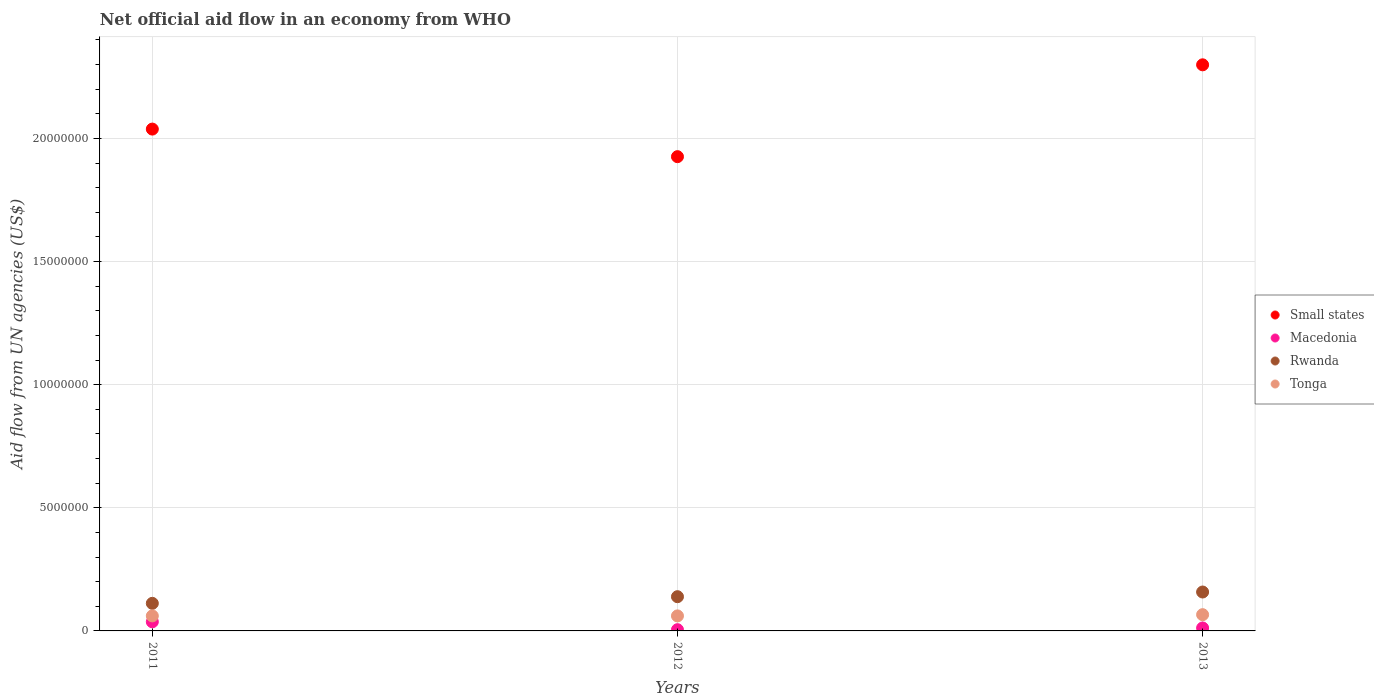How many different coloured dotlines are there?
Make the answer very short. 4. Across all years, what is the minimum net official aid flow in Macedonia?
Offer a terse response. 5.00e+04. What is the total net official aid flow in Tonga in the graph?
Your answer should be very brief. 1.88e+06. What is the difference between the net official aid flow in Macedonia in 2012 and that in 2013?
Give a very brief answer. -7.00e+04. What is the difference between the net official aid flow in Tonga in 2011 and the net official aid flow in Small states in 2013?
Your answer should be very brief. -2.24e+07. What is the average net official aid flow in Small states per year?
Your answer should be very brief. 2.09e+07. In the year 2013, what is the difference between the net official aid flow in Tonga and net official aid flow in Macedonia?
Your response must be concise. 5.40e+05. What is the ratio of the net official aid flow in Rwanda in 2012 to that in 2013?
Provide a short and direct response. 0.88. Is the net official aid flow in Macedonia in 2011 less than that in 2012?
Offer a terse response. No. Is the difference between the net official aid flow in Tonga in 2011 and 2012 greater than the difference between the net official aid flow in Macedonia in 2011 and 2012?
Provide a succinct answer. No. What is the difference between the highest and the second highest net official aid flow in Small states?
Make the answer very short. 2.61e+06. In how many years, is the net official aid flow in Macedonia greater than the average net official aid flow in Macedonia taken over all years?
Offer a very short reply. 1. Is it the case that in every year, the sum of the net official aid flow in Rwanda and net official aid flow in Small states  is greater than the sum of net official aid flow in Tonga and net official aid flow in Macedonia?
Your answer should be compact. Yes. Is it the case that in every year, the sum of the net official aid flow in Macedonia and net official aid flow in Rwanda  is greater than the net official aid flow in Tonga?
Provide a succinct answer. Yes. Does the net official aid flow in Macedonia monotonically increase over the years?
Provide a succinct answer. No. Is the net official aid flow in Macedonia strictly less than the net official aid flow in Tonga over the years?
Ensure brevity in your answer.  Yes. How many dotlines are there?
Offer a terse response. 4. How many years are there in the graph?
Give a very brief answer. 3. What is the difference between two consecutive major ticks on the Y-axis?
Give a very brief answer. 5.00e+06. Are the values on the major ticks of Y-axis written in scientific E-notation?
Your answer should be very brief. No. Does the graph contain any zero values?
Offer a terse response. No. Does the graph contain grids?
Keep it short and to the point. Yes. Where does the legend appear in the graph?
Your answer should be very brief. Center right. How many legend labels are there?
Provide a short and direct response. 4. How are the legend labels stacked?
Your answer should be very brief. Vertical. What is the title of the graph?
Keep it short and to the point. Net official aid flow in an economy from WHO. Does "Arab World" appear as one of the legend labels in the graph?
Keep it short and to the point. No. What is the label or title of the X-axis?
Your response must be concise. Years. What is the label or title of the Y-axis?
Provide a succinct answer. Aid flow from UN agencies (US$). What is the Aid flow from UN agencies (US$) in Small states in 2011?
Keep it short and to the point. 2.04e+07. What is the Aid flow from UN agencies (US$) of Rwanda in 2011?
Ensure brevity in your answer.  1.12e+06. What is the Aid flow from UN agencies (US$) of Tonga in 2011?
Ensure brevity in your answer.  6.10e+05. What is the Aid flow from UN agencies (US$) in Small states in 2012?
Your answer should be compact. 1.93e+07. What is the Aid flow from UN agencies (US$) in Macedonia in 2012?
Your answer should be compact. 5.00e+04. What is the Aid flow from UN agencies (US$) of Rwanda in 2012?
Offer a terse response. 1.39e+06. What is the Aid flow from UN agencies (US$) in Small states in 2013?
Give a very brief answer. 2.30e+07. What is the Aid flow from UN agencies (US$) of Macedonia in 2013?
Provide a short and direct response. 1.20e+05. What is the Aid flow from UN agencies (US$) of Rwanda in 2013?
Offer a terse response. 1.58e+06. Across all years, what is the maximum Aid flow from UN agencies (US$) in Small states?
Your answer should be very brief. 2.30e+07. Across all years, what is the maximum Aid flow from UN agencies (US$) in Macedonia?
Offer a very short reply. 3.70e+05. Across all years, what is the maximum Aid flow from UN agencies (US$) in Rwanda?
Provide a short and direct response. 1.58e+06. Across all years, what is the maximum Aid flow from UN agencies (US$) of Tonga?
Your response must be concise. 6.60e+05. Across all years, what is the minimum Aid flow from UN agencies (US$) in Small states?
Give a very brief answer. 1.93e+07. Across all years, what is the minimum Aid flow from UN agencies (US$) in Macedonia?
Your answer should be very brief. 5.00e+04. Across all years, what is the minimum Aid flow from UN agencies (US$) in Rwanda?
Offer a very short reply. 1.12e+06. Across all years, what is the minimum Aid flow from UN agencies (US$) in Tonga?
Make the answer very short. 6.10e+05. What is the total Aid flow from UN agencies (US$) in Small states in the graph?
Keep it short and to the point. 6.26e+07. What is the total Aid flow from UN agencies (US$) in Macedonia in the graph?
Offer a terse response. 5.40e+05. What is the total Aid flow from UN agencies (US$) of Rwanda in the graph?
Provide a short and direct response. 4.09e+06. What is the total Aid flow from UN agencies (US$) of Tonga in the graph?
Provide a succinct answer. 1.88e+06. What is the difference between the Aid flow from UN agencies (US$) in Small states in 2011 and that in 2012?
Keep it short and to the point. 1.12e+06. What is the difference between the Aid flow from UN agencies (US$) of Macedonia in 2011 and that in 2012?
Ensure brevity in your answer.  3.20e+05. What is the difference between the Aid flow from UN agencies (US$) of Small states in 2011 and that in 2013?
Provide a short and direct response. -2.61e+06. What is the difference between the Aid flow from UN agencies (US$) in Rwanda in 2011 and that in 2013?
Give a very brief answer. -4.60e+05. What is the difference between the Aid flow from UN agencies (US$) in Small states in 2012 and that in 2013?
Provide a succinct answer. -3.73e+06. What is the difference between the Aid flow from UN agencies (US$) of Tonga in 2012 and that in 2013?
Provide a succinct answer. -5.00e+04. What is the difference between the Aid flow from UN agencies (US$) of Small states in 2011 and the Aid flow from UN agencies (US$) of Macedonia in 2012?
Provide a short and direct response. 2.03e+07. What is the difference between the Aid flow from UN agencies (US$) in Small states in 2011 and the Aid flow from UN agencies (US$) in Rwanda in 2012?
Keep it short and to the point. 1.90e+07. What is the difference between the Aid flow from UN agencies (US$) in Small states in 2011 and the Aid flow from UN agencies (US$) in Tonga in 2012?
Offer a terse response. 1.98e+07. What is the difference between the Aid flow from UN agencies (US$) of Macedonia in 2011 and the Aid flow from UN agencies (US$) of Rwanda in 2012?
Keep it short and to the point. -1.02e+06. What is the difference between the Aid flow from UN agencies (US$) of Macedonia in 2011 and the Aid flow from UN agencies (US$) of Tonga in 2012?
Your answer should be very brief. -2.40e+05. What is the difference between the Aid flow from UN agencies (US$) of Rwanda in 2011 and the Aid flow from UN agencies (US$) of Tonga in 2012?
Offer a terse response. 5.10e+05. What is the difference between the Aid flow from UN agencies (US$) of Small states in 2011 and the Aid flow from UN agencies (US$) of Macedonia in 2013?
Provide a short and direct response. 2.03e+07. What is the difference between the Aid flow from UN agencies (US$) of Small states in 2011 and the Aid flow from UN agencies (US$) of Rwanda in 2013?
Your response must be concise. 1.88e+07. What is the difference between the Aid flow from UN agencies (US$) in Small states in 2011 and the Aid flow from UN agencies (US$) in Tonga in 2013?
Your answer should be compact. 1.97e+07. What is the difference between the Aid flow from UN agencies (US$) in Macedonia in 2011 and the Aid flow from UN agencies (US$) in Rwanda in 2013?
Give a very brief answer. -1.21e+06. What is the difference between the Aid flow from UN agencies (US$) of Rwanda in 2011 and the Aid flow from UN agencies (US$) of Tonga in 2013?
Give a very brief answer. 4.60e+05. What is the difference between the Aid flow from UN agencies (US$) in Small states in 2012 and the Aid flow from UN agencies (US$) in Macedonia in 2013?
Keep it short and to the point. 1.91e+07. What is the difference between the Aid flow from UN agencies (US$) of Small states in 2012 and the Aid flow from UN agencies (US$) of Rwanda in 2013?
Keep it short and to the point. 1.77e+07. What is the difference between the Aid flow from UN agencies (US$) of Small states in 2012 and the Aid flow from UN agencies (US$) of Tonga in 2013?
Give a very brief answer. 1.86e+07. What is the difference between the Aid flow from UN agencies (US$) of Macedonia in 2012 and the Aid flow from UN agencies (US$) of Rwanda in 2013?
Keep it short and to the point. -1.53e+06. What is the difference between the Aid flow from UN agencies (US$) in Macedonia in 2012 and the Aid flow from UN agencies (US$) in Tonga in 2013?
Your response must be concise. -6.10e+05. What is the difference between the Aid flow from UN agencies (US$) in Rwanda in 2012 and the Aid flow from UN agencies (US$) in Tonga in 2013?
Offer a very short reply. 7.30e+05. What is the average Aid flow from UN agencies (US$) in Small states per year?
Give a very brief answer. 2.09e+07. What is the average Aid flow from UN agencies (US$) in Macedonia per year?
Provide a succinct answer. 1.80e+05. What is the average Aid flow from UN agencies (US$) of Rwanda per year?
Provide a short and direct response. 1.36e+06. What is the average Aid flow from UN agencies (US$) of Tonga per year?
Offer a terse response. 6.27e+05. In the year 2011, what is the difference between the Aid flow from UN agencies (US$) of Small states and Aid flow from UN agencies (US$) of Macedonia?
Give a very brief answer. 2.00e+07. In the year 2011, what is the difference between the Aid flow from UN agencies (US$) in Small states and Aid flow from UN agencies (US$) in Rwanda?
Offer a terse response. 1.93e+07. In the year 2011, what is the difference between the Aid flow from UN agencies (US$) of Small states and Aid flow from UN agencies (US$) of Tonga?
Offer a terse response. 1.98e+07. In the year 2011, what is the difference between the Aid flow from UN agencies (US$) of Macedonia and Aid flow from UN agencies (US$) of Rwanda?
Keep it short and to the point. -7.50e+05. In the year 2011, what is the difference between the Aid flow from UN agencies (US$) of Rwanda and Aid flow from UN agencies (US$) of Tonga?
Give a very brief answer. 5.10e+05. In the year 2012, what is the difference between the Aid flow from UN agencies (US$) in Small states and Aid flow from UN agencies (US$) in Macedonia?
Give a very brief answer. 1.92e+07. In the year 2012, what is the difference between the Aid flow from UN agencies (US$) of Small states and Aid flow from UN agencies (US$) of Rwanda?
Your response must be concise. 1.79e+07. In the year 2012, what is the difference between the Aid flow from UN agencies (US$) in Small states and Aid flow from UN agencies (US$) in Tonga?
Your answer should be compact. 1.86e+07. In the year 2012, what is the difference between the Aid flow from UN agencies (US$) in Macedonia and Aid flow from UN agencies (US$) in Rwanda?
Offer a terse response. -1.34e+06. In the year 2012, what is the difference between the Aid flow from UN agencies (US$) of Macedonia and Aid flow from UN agencies (US$) of Tonga?
Your response must be concise. -5.60e+05. In the year 2012, what is the difference between the Aid flow from UN agencies (US$) in Rwanda and Aid flow from UN agencies (US$) in Tonga?
Offer a very short reply. 7.80e+05. In the year 2013, what is the difference between the Aid flow from UN agencies (US$) of Small states and Aid flow from UN agencies (US$) of Macedonia?
Ensure brevity in your answer.  2.29e+07. In the year 2013, what is the difference between the Aid flow from UN agencies (US$) in Small states and Aid flow from UN agencies (US$) in Rwanda?
Ensure brevity in your answer.  2.14e+07. In the year 2013, what is the difference between the Aid flow from UN agencies (US$) of Small states and Aid flow from UN agencies (US$) of Tonga?
Ensure brevity in your answer.  2.23e+07. In the year 2013, what is the difference between the Aid flow from UN agencies (US$) in Macedonia and Aid flow from UN agencies (US$) in Rwanda?
Provide a succinct answer. -1.46e+06. In the year 2013, what is the difference between the Aid flow from UN agencies (US$) in Macedonia and Aid flow from UN agencies (US$) in Tonga?
Your answer should be very brief. -5.40e+05. In the year 2013, what is the difference between the Aid flow from UN agencies (US$) in Rwanda and Aid flow from UN agencies (US$) in Tonga?
Make the answer very short. 9.20e+05. What is the ratio of the Aid flow from UN agencies (US$) in Small states in 2011 to that in 2012?
Offer a very short reply. 1.06. What is the ratio of the Aid flow from UN agencies (US$) of Rwanda in 2011 to that in 2012?
Your response must be concise. 0.81. What is the ratio of the Aid flow from UN agencies (US$) in Tonga in 2011 to that in 2012?
Offer a very short reply. 1. What is the ratio of the Aid flow from UN agencies (US$) of Small states in 2011 to that in 2013?
Your answer should be compact. 0.89. What is the ratio of the Aid flow from UN agencies (US$) in Macedonia in 2011 to that in 2013?
Provide a short and direct response. 3.08. What is the ratio of the Aid flow from UN agencies (US$) of Rwanda in 2011 to that in 2013?
Make the answer very short. 0.71. What is the ratio of the Aid flow from UN agencies (US$) of Tonga in 2011 to that in 2013?
Your answer should be very brief. 0.92. What is the ratio of the Aid flow from UN agencies (US$) in Small states in 2012 to that in 2013?
Provide a short and direct response. 0.84. What is the ratio of the Aid flow from UN agencies (US$) in Macedonia in 2012 to that in 2013?
Make the answer very short. 0.42. What is the ratio of the Aid flow from UN agencies (US$) in Rwanda in 2012 to that in 2013?
Provide a short and direct response. 0.88. What is the ratio of the Aid flow from UN agencies (US$) of Tonga in 2012 to that in 2013?
Ensure brevity in your answer.  0.92. What is the difference between the highest and the second highest Aid flow from UN agencies (US$) in Small states?
Offer a very short reply. 2.61e+06. What is the difference between the highest and the second highest Aid flow from UN agencies (US$) of Macedonia?
Make the answer very short. 2.50e+05. What is the difference between the highest and the second highest Aid flow from UN agencies (US$) in Rwanda?
Your answer should be compact. 1.90e+05. What is the difference between the highest and the lowest Aid flow from UN agencies (US$) of Small states?
Your answer should be compact. 3.73e+06. What is the difference between the highest and the lowest Aid flow from UN agencies (US$) in Macedonia?
Keep it short and to the point. 3.20e+05. What is the difference between the highest and the lowest Aid flow from UN agencies (US$) of Rwanda?
Provide a succinct answer. 4.60e+05. What is the difference between the highest and the lowest Aid flow from UN agencies (US$) of Tonga?
Provide a succinct answer. 5.00e+04. 